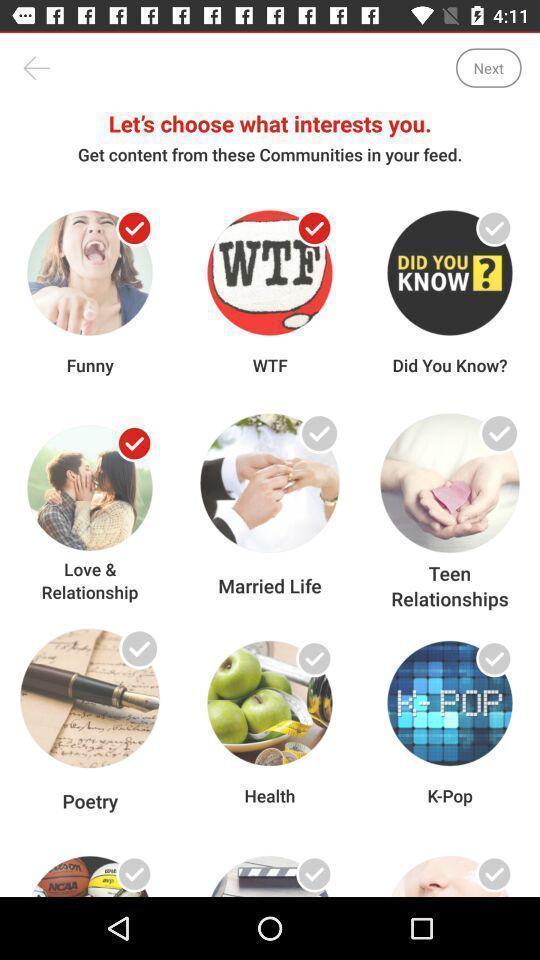Provide a textual representation of this image. Screen displaying the multiple communities to choose. 